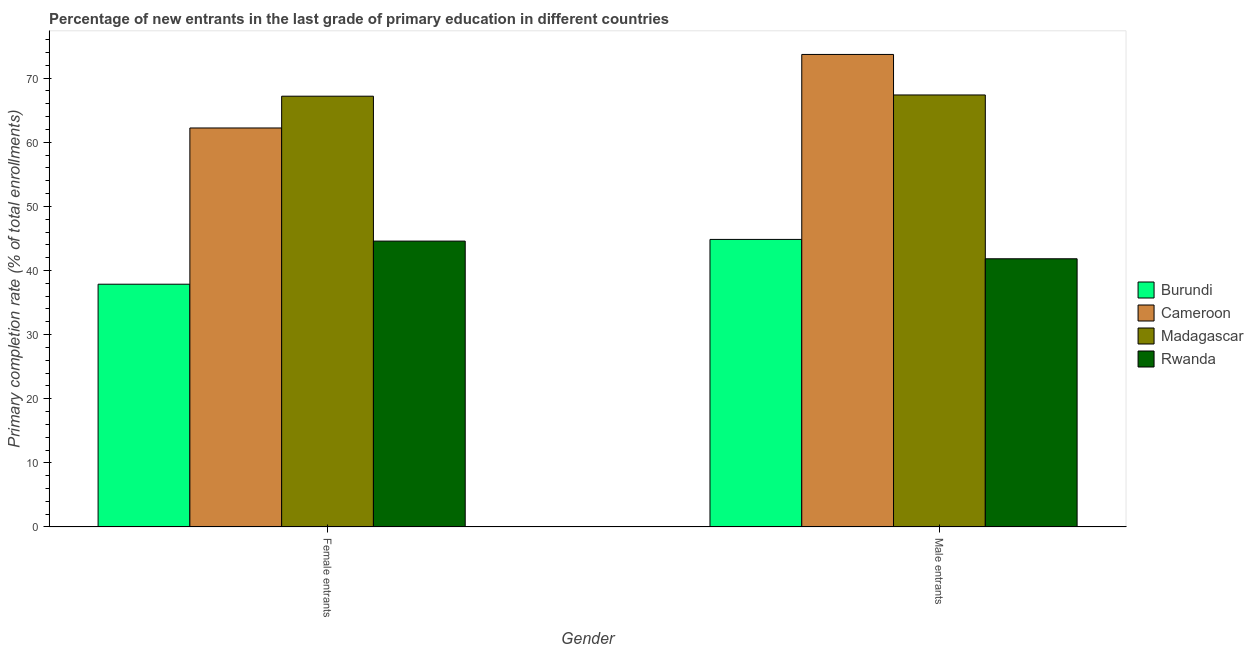How many different coloured bars are there?
Your response must be concise. 4. How many groups of bars are there?
Ensure brevity in your answer.  2. Are the number of bars per tick equal to the number of legend labels?
Your response must be concise. Yes. What is the label of the 2nd group of bars from the left?
Provide a short and direct response. Male entrants. What is the primary completion rate of male entrants in Madagascar?
Provide a succinct answer. 67.38. Across all countries, what is the maximum primary completion rate of female entrants?
Offer a very short reply. 67.19. Across all countries, what is the minimum primary completion rate of female entrants?
Offer a terse response. 37.86. In which country was the primary completion rate of female entrants maximum?
Provide a short and direct response. Madagascar. In which country was the primary completion rate of female entrants minimum?
Offer a terse response. Burundi. What is the total primary completion rate of male entrants in the graph?
Your response must be concise. 227.77. What is the difference between the primary completion rate of female entrants in Madagascar and that in Rwanda?
Provide a short and direct response. 22.6. What is the difference between the primary completion rate of female entrants in Rwanda and the primary completion rate of male entrants in Cameroon?
Your answer should be compact. -29.11. What is the average primary completion rate of female entrants per country?
Ensure brevity in your answer.  52.97. What is the difference between the primary completion rate of male entrants and primary completion rate of female entrants in Cameroon?
Your response must be concise. 11.47. What is the ratio of the primary completion rate of male entrants in Cameroon to that in Rwanda?
Make the answer very short. 1.76. Is the primary completion rate of female entrants in Cameroon less than that in Madagascar?
Provide a short and direct response. Yes. What does the 1st bar from the left in Male entrants represents?
Make the answer very short. Burundi. What does the 2nd bar from the right in Female entrants represents?
Your response must be concise. Madagascar. How many bars are there?
Your answer should be compact. 8. Are all the bars in the graph horizontal?
Ensure brevity in your answer.  No. Where does the legend appear in the graph?
Your answer should be very brief. Center right. How many legend labels are there?
Give a very brief answer. 4. How are the legend labels stacked?
Offer a terse response. Vertical. What is the title of the graph?
Offer a very short reply. Percentage of new entrants in the last grade of primary education in different countries. Does "Belarus" appear as one of the legend labels in the graph?
Provide a short and direct response. No. What is the label or title of the Y-axis?
Your answer should be compact. Primary completion rate (% of total enrollments). What is the Primary completion rate (% of total enrollments) of Burundi in Female entrants?
Provide a short and direct response. 37.86. What is the Primary completion rate (% of total enrollments) in Cameroon in Female entrants?
Your response must be concise. 62.23. What is the Primary completion rate (% of total enrollments) in Madagascar in Female entrants?
Keep it short and to the point. 67.19. What is the Primary completion rate (% of total enrollments) of Rwanda in Female entrants?
Give a very brief answer. 44.59. What is the Primary completion rate (% of total enrollments) of Burundi in Male entrants?
Ensure brevity in your answer.  44.85. What is the Primary completion rate (% of total enrollments) of Cameroon in Male entrants?
Make the answer very short. 73.7. What is the Primary completion rate (% of total enrollments) of Madagascar in Male entrants?
Make the answer very short. 67.38. What is the Primary completion rate (% of total enrollments) in Rwanda in Male entrants?
Make the answer very short. 41.83. Across all Gender, what is the maximum Primary completion rate (% of total enrollments) in Burundi?
Give a very brief answer. 44.85. Across all Gender, what is the maximum Primary completion rate (% of total enrollments) in Cameroon?
Provide a succinct answer. 73.7. Across all Gender, what is the maximum Primary completion rate (% of total enrollments) of Madagascar?
Offer a terse response. 67.38. Across all Gender, what is the maximum Primary completion rate (% of total enrollments) in Rwanda?
Make the answer very short. 44.59. Across all Gender, what is the minimum Primary completion rate (% of total enrollments) in Burundi?
Keep it short and to the point. 37.86. Across all Gender, what is the minimum Primary completion rate (% of total enrollments) in Cameroon?
Your response must be concise. 62.23. Across all Gender, what is the minimum Primary completion rate (% of total enrollments) of Madagascar?
Your response must be concise. 67.19. Across all Gender, what is the minimum Primary completion rate (% of total enrollments) in Rwanda?
Ensure brevity in your answer.  41.83. What is the total Primary completion rate (% of total enrollments) in Burundi in the graph?
Offer a very short reply. 82.72. What is the total Primary completion rate (% of total enrollments) in Cameroon in the graph?
Offer a terse response. 135.93. What is the total Primary completion rate (% of total enrollments) in Madagascar in the graph?
Ensure brevity in your answer.  134.57. What is the total Primary completion rate (% of total enrollments) of Rwanda in the graph?
Ensure brevity in your answer.  86.42. What is the difference between the Primary completion rate (% of total enrollments) of Burundi in Female entrants and that in Male entrants?
Your answer should be compact. -6.99. What is the difference between the Primary completion rate (% of total enrollments) of Cameroon in Female entrants and that in Male entrants?
Your answer should be very brief. -11.47. What is the difference between the Primary completion rate (% of total enrollments) of Madagascar in Female entrants and that in Male entrants?
Offer a very short reply. -0.19. What is the difference between the Primary completion rate (% of total enrollments) in Rwanda in Female entrants and that in Male entrants?
Provide a short and direct response. 2.76. What is the difference between the Primary completion rate (% of total enrollments) of Burundi in Female entrants and the Primary completion rate (% of total enrollments) of Cameroon in Male entrants?
Provide a succinct answer. -35.83. What is the difference between the Primary completion rate (% of total enrollments) in Burundi in Female entrants and the Primary completion rate (% of total enrollments) in Madagascar in Male entrants?
Offer a very short reply. -29.52. What is the difference between the Primary completion rate (% of total enrollments) of Burundi in Female entrants and the Primary completion rate (% of total enrollments) of Rwanda in Male entrants?
Offer a very short reply. -3.97. What is the difference between the Primary completion rate (% of total enrollments) of Cameroon in Female entrants and the Primary completion rate (% of total enrollments) of Madagascar in Male entrants?
Your answer should be very brief. -5.15. What is the difference between the Primary completion rate (% of total enrollments) of Cameroon in Female entrants and the Primary completion rate (% of total enrollments) of Rwanda in Male entrants?
Provide a succinct answer. 20.4. What is the difference between the Primary completion rate (% of total enrollments) of Madagascar in Female entrants and the Primary completion rate (% of total enrollments) of Rwanda in Male entrants?
Your response must be concise. 25.36. What is the average Primary completion rate (% of total enrollments) in Burundi per Gender?
Your answer should be compact. 41.36. What is the average Primary completion rate (% of total enrollments) of Cameroon per Gender?
Provide a short and direct response. 67.97. What is the average Primary completion rate (% of total enrollments) in Madagascar per Gender?
Your response must be concise. 67.29. What is the average Primary completion rate (% of total enrollments) of Rwanda per Gender?
Give a very brief answer. 43.21. What is the difference between the Primary completion rate (% of total enrollments) in Burundi and Primary completion rate (% of total enrollments) in Cameroon in Female entrants?
Your answer should be compact. -24.37. What is the difference between the Primary completion rate (% of total enrollments) of Burundi and Primary completion rate (% of total enrollments) of Madagascar in Female entrants?
Your answer should be very brief. -29.32. What is the difference between the Primary completion rate (% of total enrollments) of Burundi and Primary completion rate (% of total enrollments) of Rwanda in Female entrants?
Keep it short and to the point. -6.72. What is the difference between the Primary completion rate (% of total enrollments) in Cameroon and Primary completion rate (% of total enrollments) in Madagascar in Female entrants?
Ensure brevity in your answer.  -4.96. What is the difference between the Primary completion rate (% of total enrollments) in Cameroon and Primary completion rate (% of total enrollments) in Rwanda in Female entrants?
Your answer should be compact. 17.64. What is the difference between the Primary completion rate (% of total enrollments) in Madagascar and Primary completion rate (% of total enrollments) in Rwanda in Female entrants?
Provide a short and direct response. 22.6. What is the difference between the Primary completion rate (% of total enrollments) in Burundi and Primary completion rate (% of total enrollments) in Cameroon in Male entrants?
Provide a succinct answer. -28.85. What is the difference between the Primary completion rate (% of total enrollments) in Burundi and Primary completion rate (% of total enrollments) in Madagascar in Male entrants?
Provide a short and direct response. -22.53. What is the difference between the Primary completion rate (% of total enrollments) of Burundi and Primary completion rate (% of total enrollments) of Rwanda in Male entrants?
Your response must be concise. 3.02. What is the difference between the Primary completion rate (% of total enrollments) in Cameroon and Primary completion rate (% of total enrollments) in Madagascar in Male entrants?
Keep it short and to the point. 6.32. What is the difference between the Primary completion rate (% of total enrollments) in Cameroon and Primary completion rate (% of total enrollments) in Rwanda in Male entrants?
Offer a terse response. 31.87. What is the difference between the Primary completion rate (% of total enrollments) in Madagascar and Primary completion rate (% of total enrollments) in Rwanda in Male entrants?
Your response must be concise. 25.55. What is the ratio of the Primary completion rate (% of total enrollments) of Burundi in Female entrants to that in Male entrants?
Your answer should be compact. 0.84. What is the ratio of the Primary completion rate (% of total enrollments) in Cameroon in Female entrants to that in Male entrants?
Keep it short and to the point. 0.84. What is the ratio of the Primary completion rate (% of total enrollments) of Rwanda in Female entrants to that in Male entrants?
Make the answer very short. 1.07. What is the difference between the highest and the second highest Primary completion rate (% of total enrollments) in Burundi?
Offer a very short reply. 6.99. What is the difference between the highest and the second highest Primary completion rate (% of total enrollments) of Cameroon?
Your response must be concise. 11.47. What is the difference between the highest and the second highest Primary completion rate (% of total enrollments) in Madagascar?
Offer a terse response. 0.19. What is the difference between the highest and the second highest Primary completion rate (% of total enrollments) of Rwanda?
Provide a succinct answer. 2.76. What is the difference between the highest and the lowest Primary completion rate (% of total enrollments) in Burundi?
Make the answer very short. 6.99. What is the difference between the highest and the lowest Primary completion rate (% of total enrollments) of Cameroon?
Offer a very short reply. 11.47. What is the difference between the highest and the lowest Primary completion rate (% of total enrollments) of Madagascar?
Keep it short and to the point. 0.19. What is the difference between the highest and the lowest Primary completion rate (% of total enrollments) of Rwanda?
Keep it short and to the point. 2.76. 